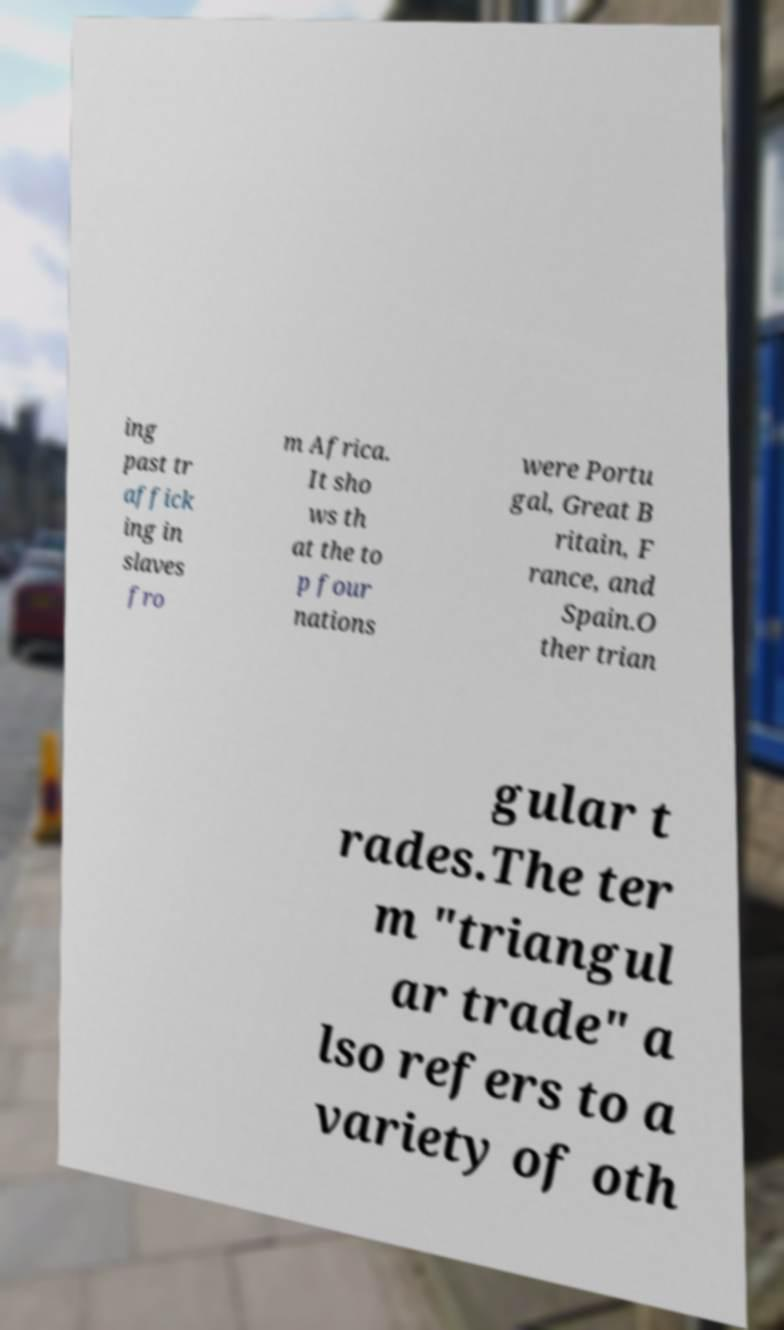What messages or text are displayed in this image? I need them in a readable, typed format. ing past tr affick ing in slaves fro m Africa. It sho ws th at the to p four nations were Portu gal, Great B ritain, F rance, and Spain.O ther trian gular t rades.The ter m "triangul ar trade" a lso refers to a variety of oth 